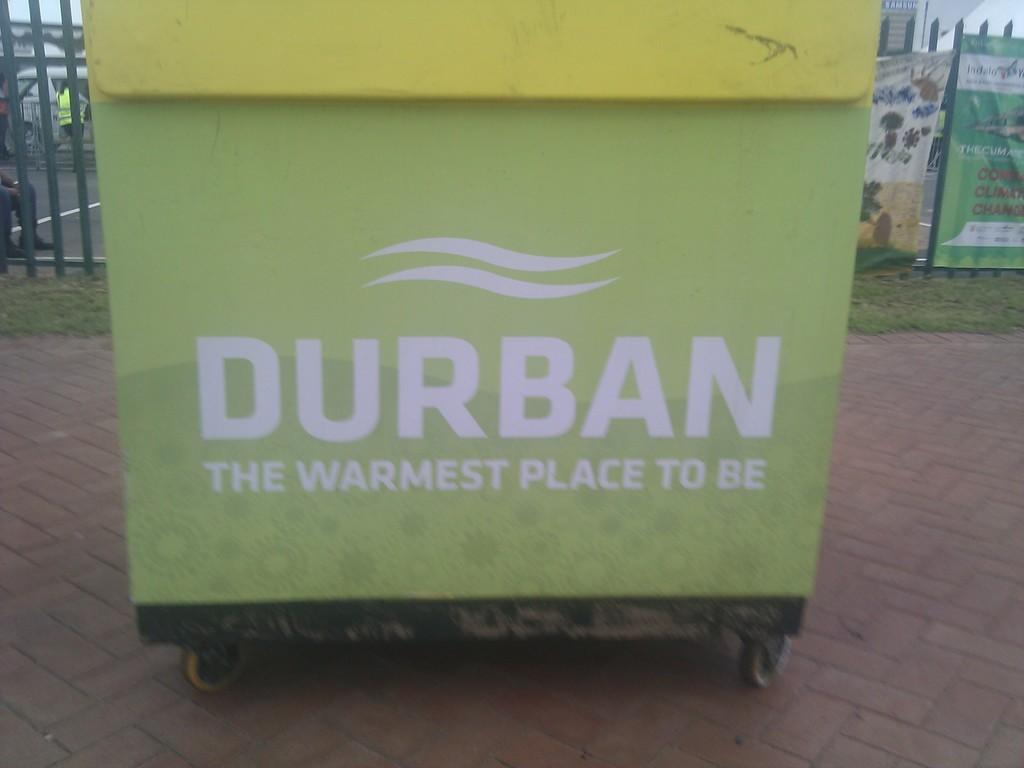What is the movable object in the front of the image? There is a movable road in the front of the image. What is written on the movable road? Something is written on the road. What can be seen in the background of the image? In the background of the image, there is a grill, grass, banners, people, a vehicle, and other objects. What type of doll is fueling the vehicle in the image? There is no doll present in the image, nor is there any indication of a vehicle being fueled. 